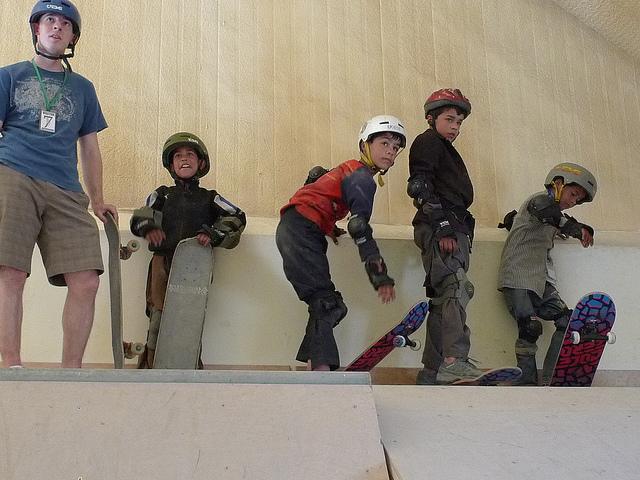What number of humans are in this shot?
Concise answer only. 5. How many of them are wearing helmets?
Give a very brief answer. 5. How many people are leaning against the wall?
Give a very brief answer. 2. Are they wearing helmets?
Write a very short answer. Yes. How many skateboards are touching the ground?
Give a very brief answer. 4. What sport is depicted?
Be succinct. Skateboarding. What kind of athletic facility is that?
Keep it brief. Skate park. Are the spectators mostly children?
Short answer required. Yes. 